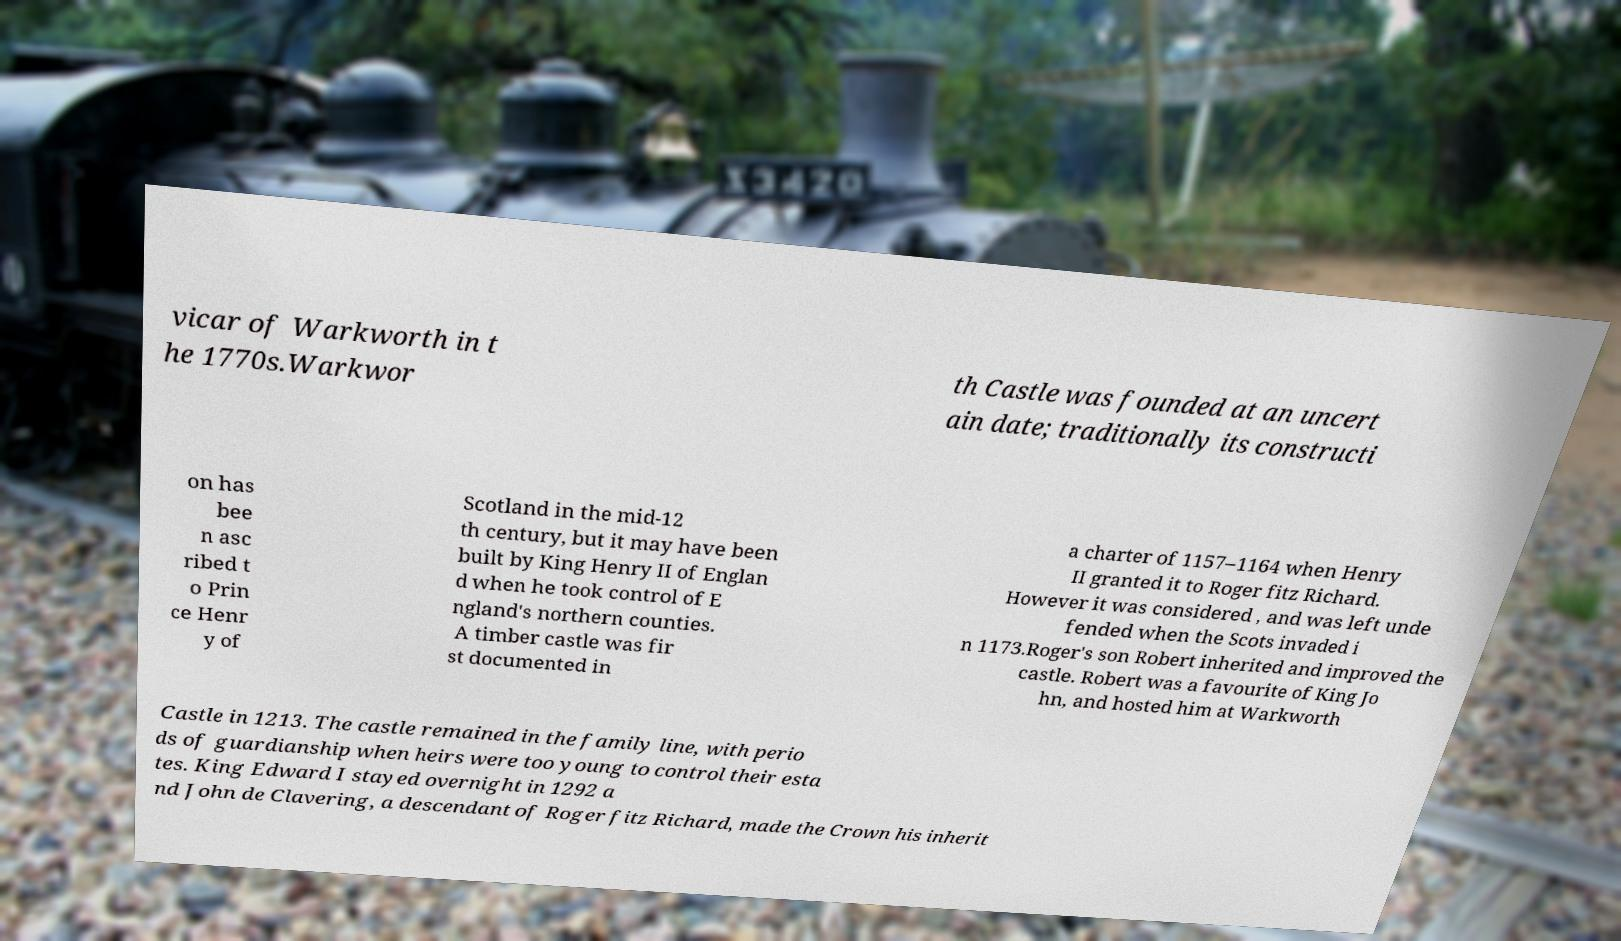What messages or text are displayed in this image? I need them in a readable, typed format. vicar of Warkworth in t he 1770s.Warkwor th Castle was founded at an uncert ain date; traditionally its constructi on has bee n asc ribed t o Prin ce Henr y of Scotland in the mid-12 th century, but it may have been built by King Henry II of Englan d when he took control of E ngland's northern counties. A timber castle was fir st documented in a charter of 1157–1164 when Henry II granted it to Roger fitz Richard. However it was considered , and was left unde fended when the Scots invaded i n 1173.Roger's son Robert inherited and improved the castle. Robert was a favourite of King Jo hn, and hosted him at Warkworth Castle in 1213. The castle remained in the family line, with perio ds of guardianship when heirs were too young to control their esta tes. King Edward I stayed overnight in 1292 a nd John de Clavering, a descendant of Roger fitz Richard, made the Crown his inherit 